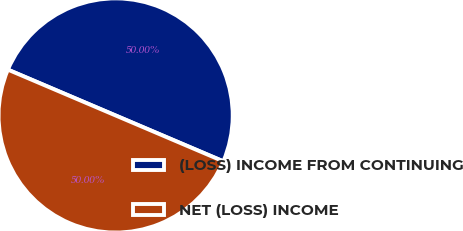<chart> <loc_0><loc_0><loc_500><loc_500><pie_chart><fcel>(LOSS) INCOME FROM CONTINUING<fcel>NET (LOSS) INCOME<nl><fcel>50.0%<fcel>50.0%<nl></chart> 